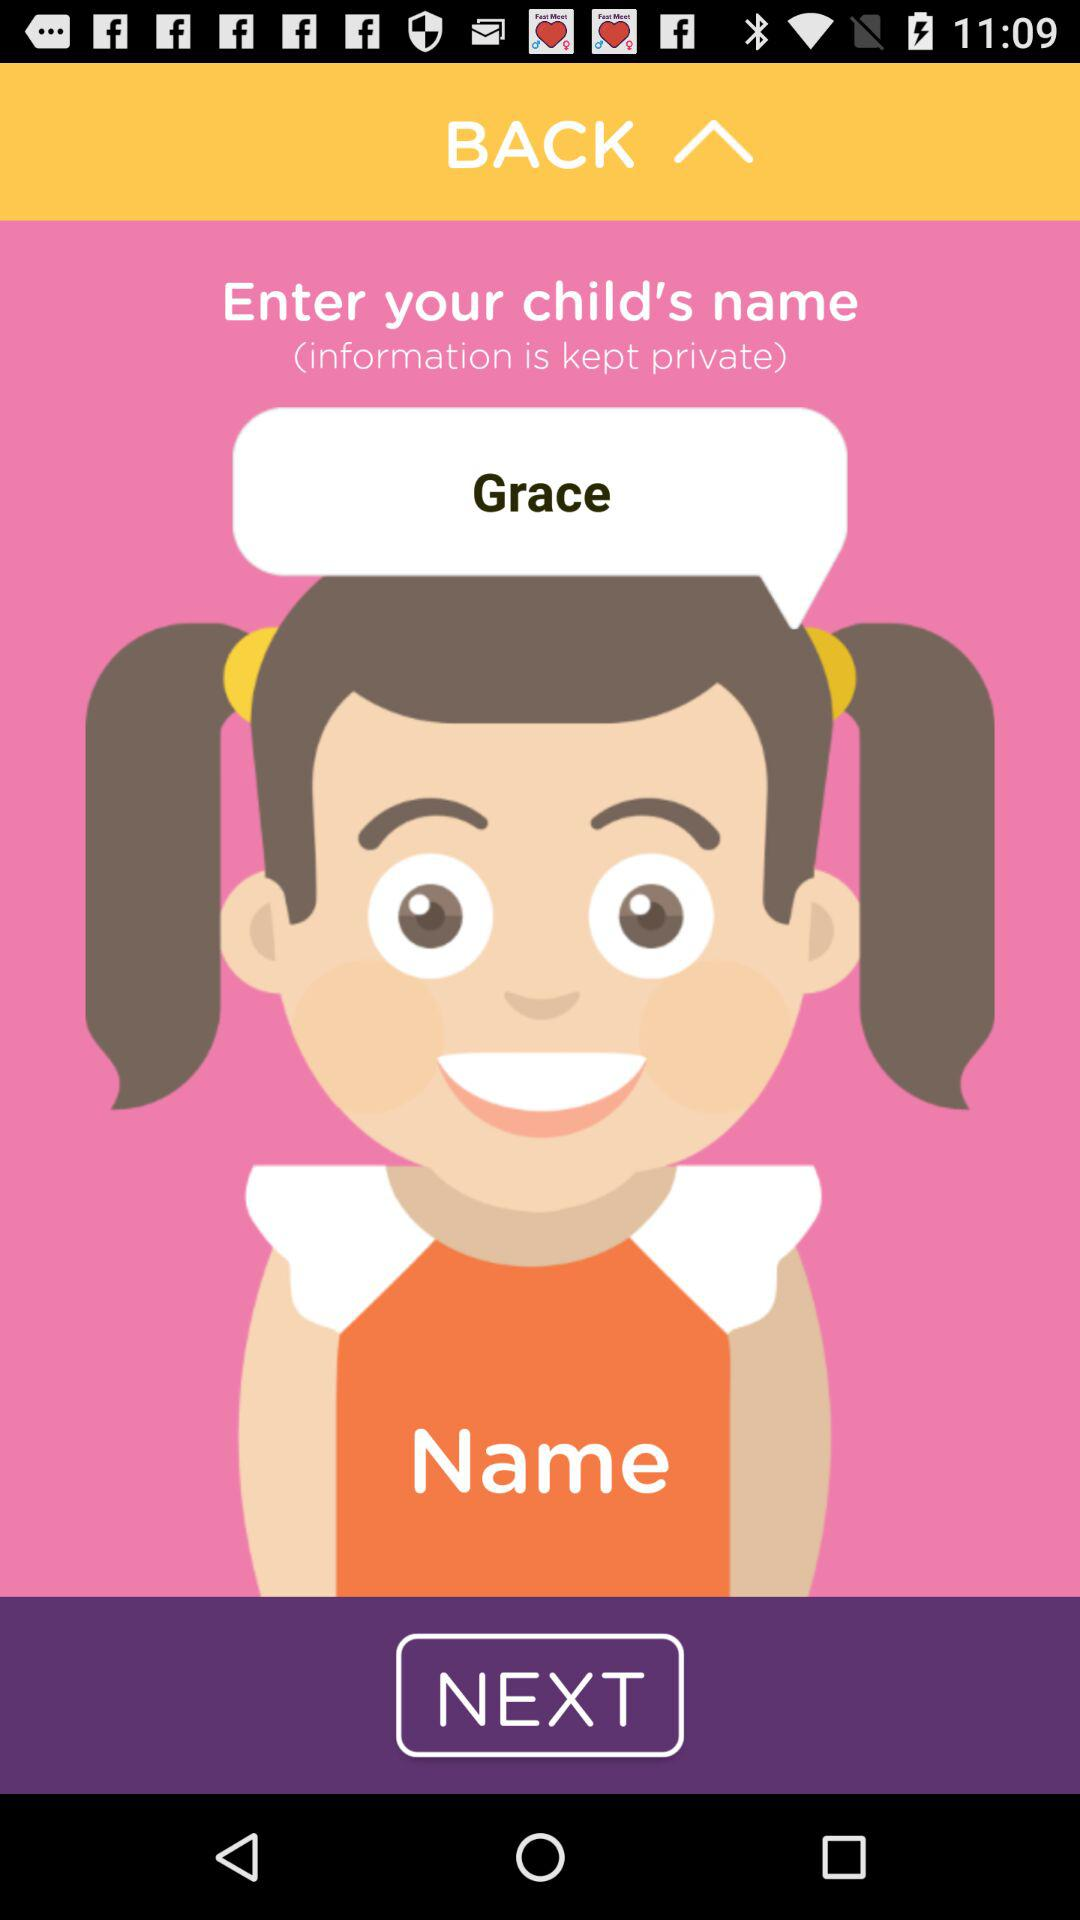What is the child's name? The child's name is Grace. 